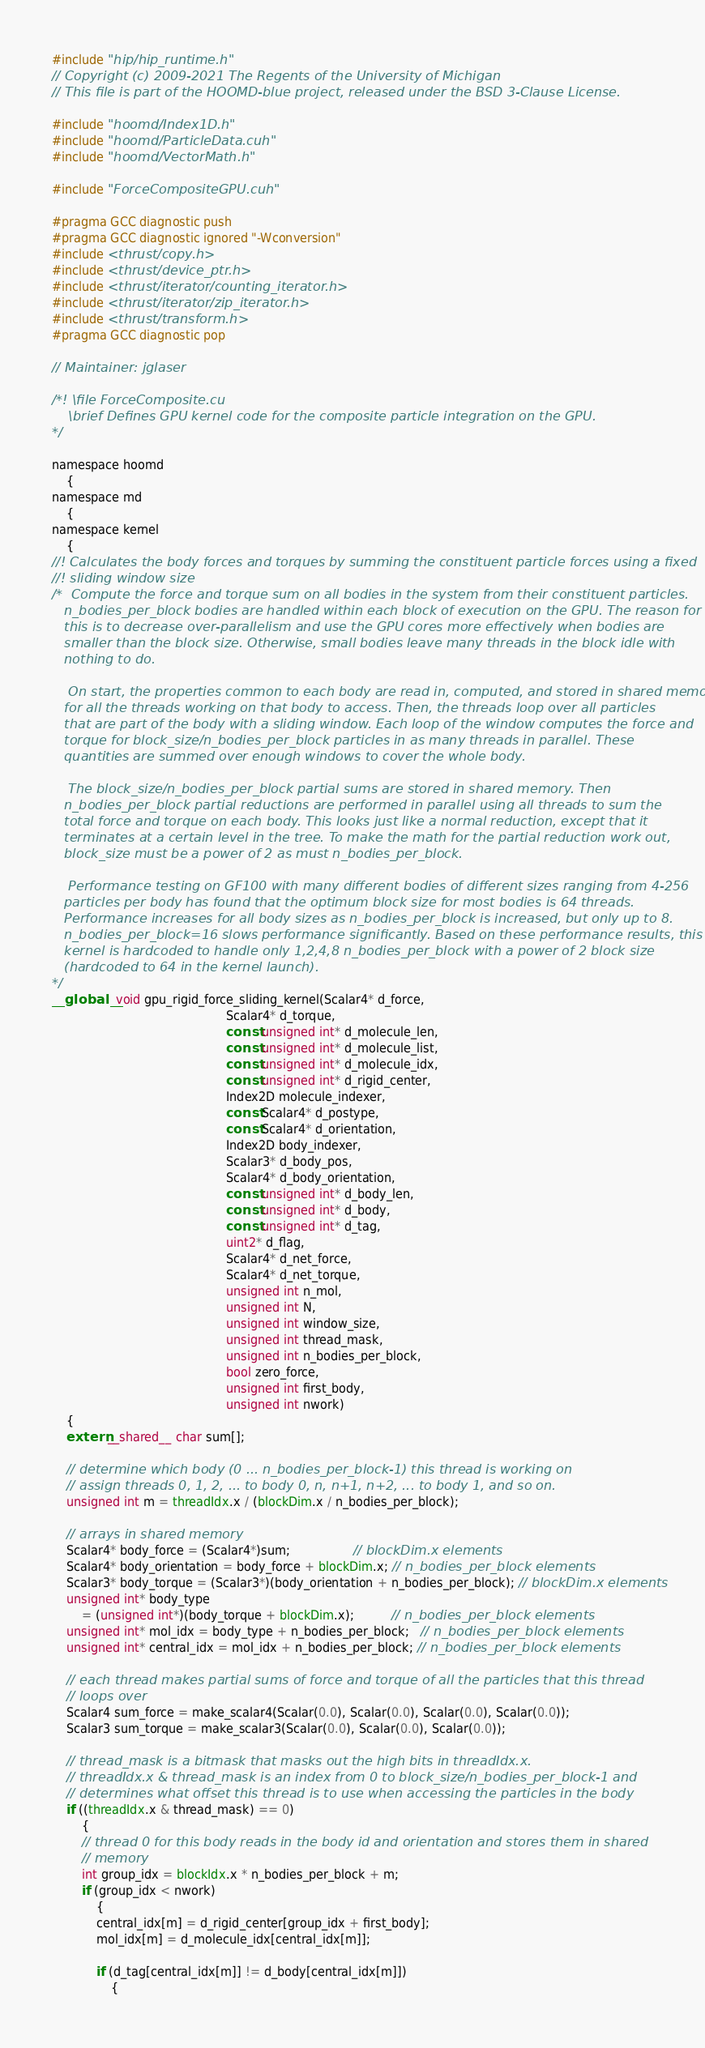<code> <loc_0><loc_0><loc_500><loc_500><_Cuda_>#include "hip/hip_runtime.h"
// Copyright (c) 2009-2021 The Regents of the University of Michigan
// This file is part of the HOOMD-blue project, released under the BSD 3-Clause License.

#include "hoomd/Index1D.h"
#include "hoomd/ParticleData.cuh"
#include "hoomd/VectorMath.h"

#include "ForceCompositeGPU.cuh"

#pragma GCC diagnostic push
#pragma GCC diagnostic ignored "-Wconversion"
#include <thrust/copy.h>
#include <thrust/device_ptr.h>
#include <thrust/iterator/counting_iterator.h>
#include <thrust/iterator/zip_iterator.h>
#include <thrust/transform.h>
#pragma GCC diagnostic pop

// Maintainer: jglaser

/*! \file ForceComposite.cu
    \brief Defines GPU kernel code for the composite particle integration on the GPU.
*/

namespace hoomd
    {
namespace md
    {
namespace kernel
    {
//! Calculates the body forces and torques by summing the constituent particle forces using a fixed
//! sliding window size
/*  Compute the force and torque sum on all bodies in the system from their constituent particles.
   n_bodies_per_block bodies are handled within each block of execution on the GPU. The reason for
   this is to decrease over-parallelism and use the GPU cores more effectively when bodies are
   smaller than the block size. Otherwise, small bodies leave many threads in the block idle with
   nothing to do.

    On start, the properties common to each body are read in, computed, and stored in shared memory
   for all the threads working on that body to access. Then, the threads loop over all particles
   that are part of the body with a sliding window. Each loop of the window computes the force and
   torque for block_size/n_bodies_per_block particles in as many threads in parallel. These
   quantities are summed over enough windows to cover the whole body.

    The block_size/n_bodies_per_block partial sums are stored in shared memory. Then
   n_bodies_per_block partial reductions are performed in parallel using all threads to sum the
   total force and torque on each body. This looks just like a normal reduction, except that it
   terminates at a certain level in the tree. To make the math for the partial reduction work out,
   block_size must be a power of 2 as must n_bodies_per_block.

    Performance testing on GF100 with many different bodies of different sizes ranging from 4-256
   particles per body has found that the optimum block size for most bodies is 64 threads.
   Performance increases for all body sizes as n_bodies_per_block is increased, but only up to 8.
   n_bodies_per_block=16 slows performance significantly. Based on these performance results, this
   kernel is hardcoded to handle only 1,2,4,8 n_bodies_per_block with a power of 2 block size
   (hardcoded to 64 in the kernel launch).
*/
__global__ void gpu_rigid_force_sliding_kernel(Scalar4* d_force,
                                               Scalar4* d_torque,
                                               const unsigned int* d_molecule_len,
                                               const unsigned int* d_molecule_list,
                                               const unsigned int* d_molecule_idx,
                                               const unsigned int* d_rigid_center,
                                               Index2D molecule_indexer,
                                               const Scalar4* d_postype,
                                               const Scalar4* d_orientation,
                                               Index2D body_indexer,
                                               Scalar3* d_body_pos,
                                               Scalar4* d_body_orientation,
                                               const unsigned int* d_body_len,
                                               const unsigned int* d_body,
                                               const unsigned int* d_tag,
                                               uint2* d_flag,
                                               Scalar4* d_net_force,
                                               Scalar4* d_net_torque,
                                               unsigned int n_mol,
                                               unsigned int N,
                                               unsigned int window_size,
                                               unsigned int thread_mask,
                                               unsigned int n_bodies_per_block,
                                               bool zero_force,
                                               unsigned int first_body,
                                               unsigned int nwork)
    {
    extern __shared__ char sum[];

    // determine which body (0 ... n_bodies_per_block-1) this thread is working on
    // assign threads 0, 1, 2, ... to body 0, n, n+1, n+2, ... to body 1, and so on.
    unsigned int m = threadIdx.x / (blockDim.x / n_bodies_per_block);

    // arrays in shared memory
    Scalar4* body_force = (Scalar4*)sum;                 // blockDim.x elements
    Scalar4* body_orientation = body_force + blockDim.x; // n_bodies_per_block elements
    Scalar3* body_torque = (Scalar3*)(body_orientation + n_bodies_per_block); // blockDim.x elements
    unsigned int* body_type
        = (unsigned int*)(body_torque + blockDim.x);          // n_bodies_per_block elements
    unsigned int* mol_idx = body_type + n_bodies_per_block;   // n_bodies_per_block elements
    unsigned int* central_idx = mol_idx + n_bodies_per_block; // n_bodies_per_block elements

    // each thread makes partial sums of force and torque of all the particles that this thread
    // loops over
    Scalar4 sum_force = make_scalar4(Scalar(0.0), Scalar(0.0), Scalar(0.0), Scalar(0.0));
    Scalar3 sum_torque = make_scalar3(Scalar(0.0), Scalar(0.0), Scalar(0.0));

    // thread_mask is a bitmask that masks out the high bits in threadIdx.x.
    // threadIdx.x & thread_mask is an index from 0 to block_size/n_bodies_per_block-1 and
    // determines what offset this thread is to use when accessing the particles in the body
    if ((threadIdx.x & thread_mask) == 0)
        {
        // thread 0 for this body reads in the body id and orientation and stores them in shared
        // memory
        int group_idx = blockIdx.x * n_bodies_per_block + m;
        if (group_idx < nwork)
            {
            central_idx[m] = d_rigid_center[group_idx + first_body];
            mol_idx[m] = d_molecule_idx[central_idx[m]];

            if (d_tag[central_idx[m]] != d_body[central_idx[m]])
                {</code> 